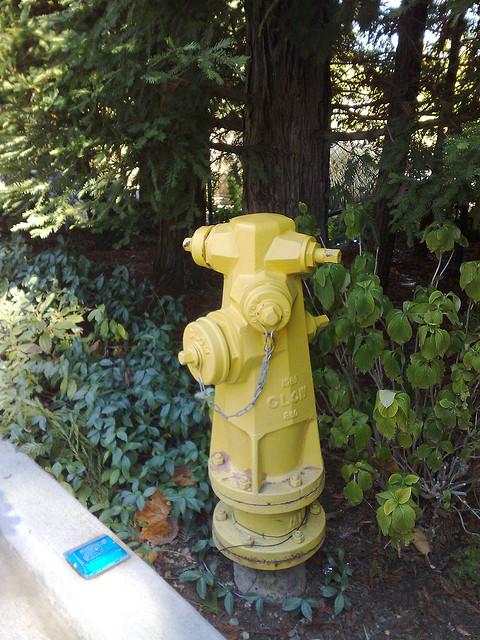Is the fire hydrant at the curb?
Short answer required. Yes. What color is the fire hydrant?
Short answer required. Yellow. Why is the chain on the hydrant?
Concise answer only. Lock. 